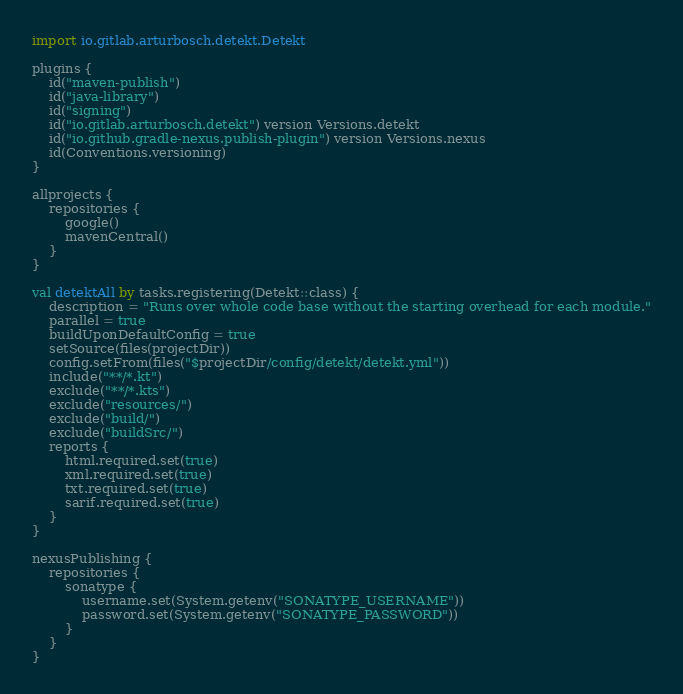Convert code to text. <code><loc_0><loc_0><loc_500><loc_500><_Kotlin_>import io.gitlab.arturbosch.detekt.Detekt

plugins {
    id("maven-publish")
    id("java-library")
    id("signing")
    id("io.gitlab.arturbosch.detekt") version Versions.detekt
    id("io.github.gradle-nexus.publish-plugin") version Versions.nexus
    id(Conventions.versioning)
}

allprojects {
    repositories {
        google()
        mavenCentral()
    }
}

val detektAll by tasks.registering(Detekt::class) {
    description = "Runs over whole code base without the starting overhead for each module."
    parallel = true
    buildUponDefaultConfig = true
    setSource(files(projectDir))
    config.setFrom(files("$projectDir/config/detekt/detekt.yml"))
    include("**/*.kt")
    exclude("**/*.kts")
    exclude("resources/")
    exclude("build/")
    exclude("buildSrc/")
    reports {
        html.required.set(true)
        xml.required.set(true)
        txt.required.set(true)
        sarif.required.set(true)
    }
}

nexusPublishing {
    repositories {
        sonatype {
            username.set(System.getenv("SONATYPE_USERNAME"))
            password.set(System.getenv("SONATYPE_PASSWORD"))
        }
    }
}
</code> 